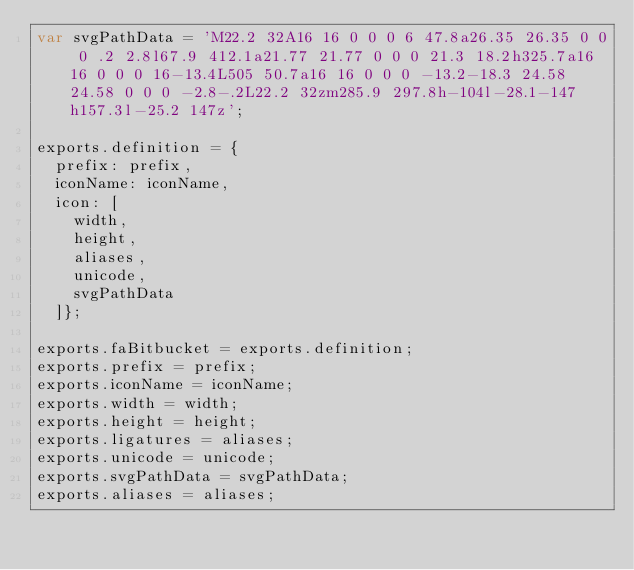Convert code to text. <code><loc_0><loc_0><loc_500><loc_500><_JavaScript_>var svgPathData = 'M22.2 32A16 16 0 0 0 6 47.8a26.35 26.35 0 0 0 .2 2.8l67.9 412.1a21.77 21.77 0 0 0 21.3 18.2h325.7a16 16 0 0 0 16-13.4L505 50.7a16 16 0 0 0 -13.2-18.3 24.58 24.58 0 0 0 -2.8-.2L22.2 32zm285.9 297.8h-104l-28.1-147h157.3l-25.2 147z';

exports.definition = {
  prefix: prefix,
  iconName: iconName,
  icon: [
    width,
    height,
    aliases,
    unicode,
    svgPathData
  ]};

exports.faBitbucket = exports.definition;
exports.prefix = prefix;
exports.iconName = iconName;
exports.width = width;
exports.height = height;
exports.ligatures = aliases;
exports.unicode = unicode;
exports.svgPathData = svgPathData;
exports.aliases = aliases;</code> 